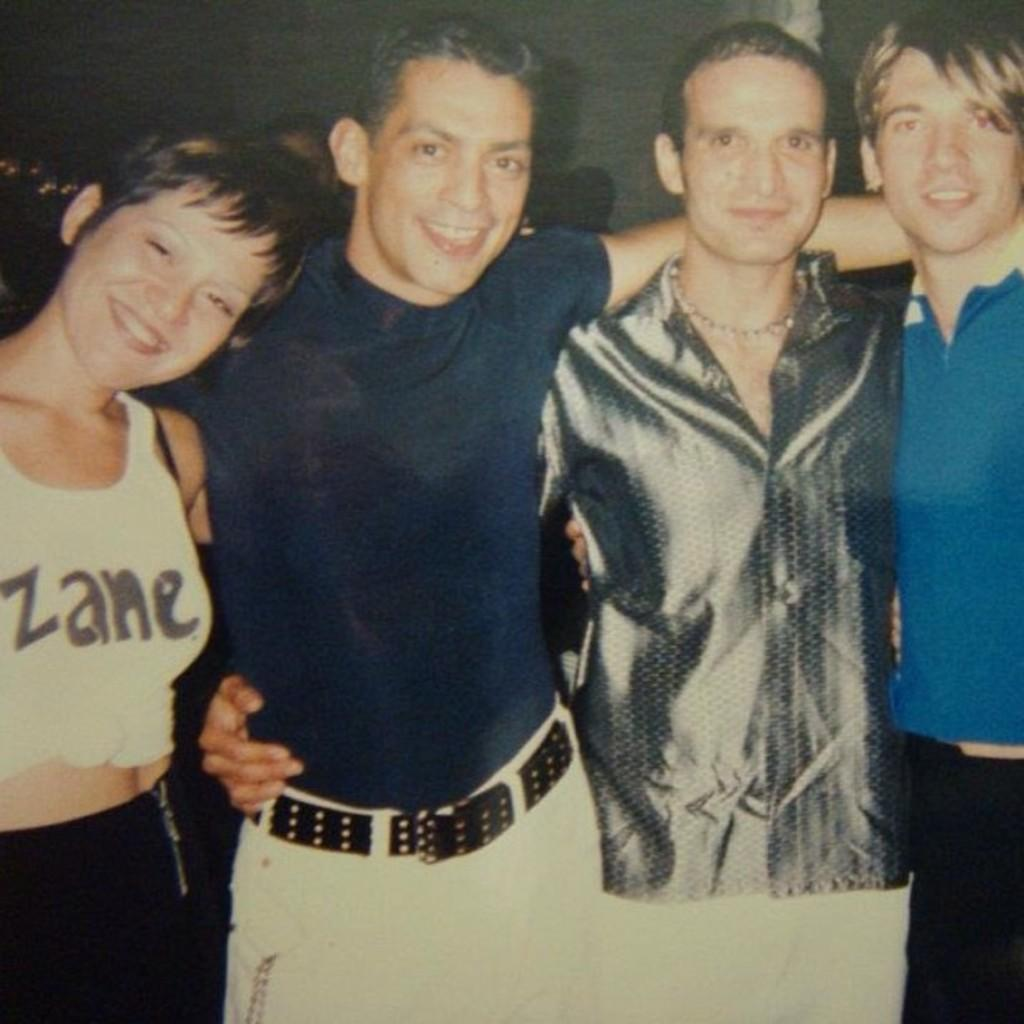How many people are in the image? There are people in the image, but the exact number is not specified. What are the people doing in the image? The people are standing and posing in the image. Can you describe the position of the people in the image? The people are standing and posing, which suggests they are likely facing the camera or each other. How many jellyfish can be seen swimming in the image? There are no jellyfish present in the image; it features people standing and posing. 